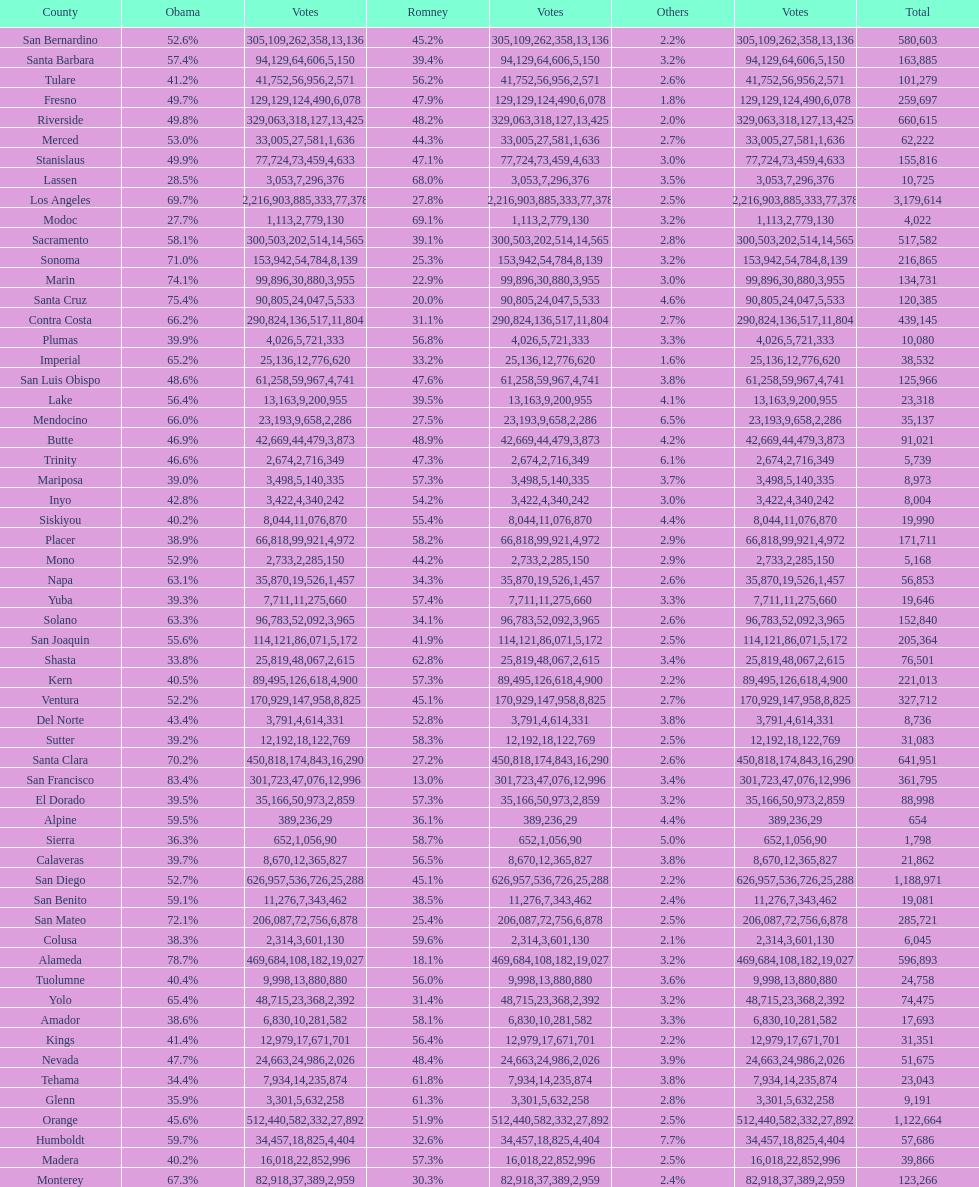What county is just before del norte on the list? Contra Costa. 